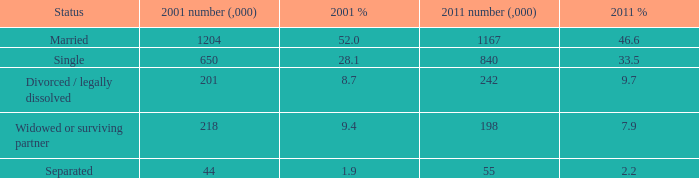Determine the percentage of 7.9 with respect to 2011%. 1.0. 